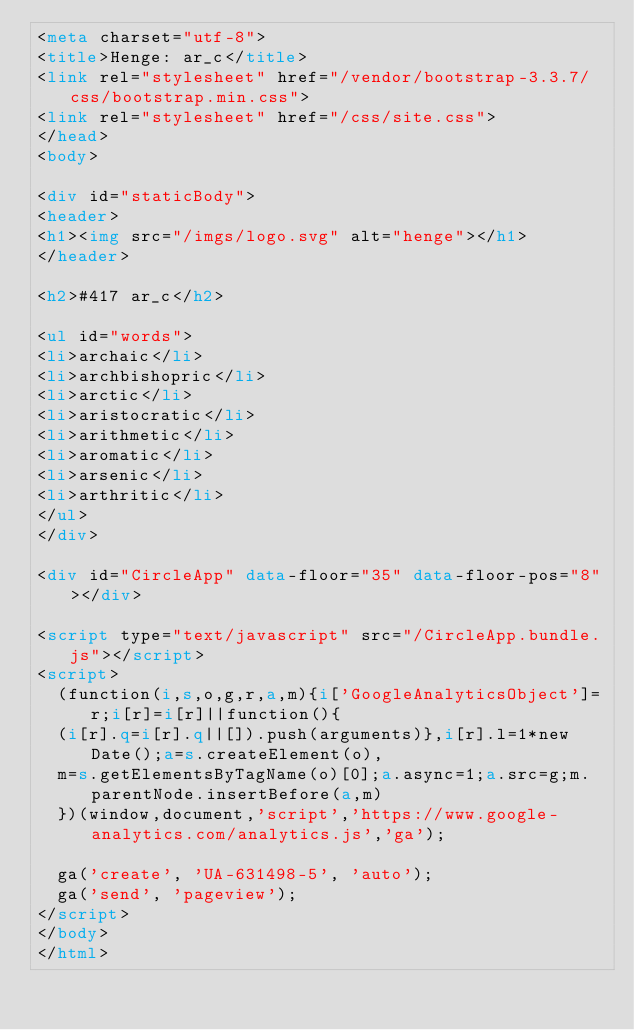<code> <loc_0><loc_0><loc_500><loc_500><_HTML_><meta charset="utf-8">
<title>Henge: ar_c</title>
<link rel="stylesheet" href="/vendor/bootstrap-3.3.7/css/bootstrap.min.css">
<link rel="stylesheet" href="/css/site.css">
</head>
<body>

<div id="staticBody">
<header>
<h1><img src="/imgs/logo.svg" alt="henge"></h1>
</header>

<h2>#417 ar_c</h2>

<ul id="words">
<li>archaic</li>
<li>archbishopric</li>
<li>arctic</li>
<li>aristocratic</li>
<li>arithmetic</li>
<li>aromatic</li>
<li>arsenic</li>
<li>arthritic</li>
</ul>
</div>

<div id="CircleApp" data-floor="35" data-floor-pos="8"></div>

<script type="text/javascript" src="/CircleApp.bundle.js"></script>
<script>
  (function(i,s,o,g,r,a,m){i['GoogleAnalyticsObject']=r;i[r]=i[r]||function(){
  (i[r].q=i[r].q||[]).push(arguments)},i[r].l=1*new Date();a=s.createElement(o),
  m=s.getElementsByTagName(o)[0];a.async=1;a.src=g;m.parentNode.insertBefore(a,m)
  })(window,document,'script','https://www.google-analytics.com/analytics.js','ga');

  ga('create', 'UA-631498-5', 'auto');
  ga('send', 'pageview');
</script>
</body>
</html>
</code> 